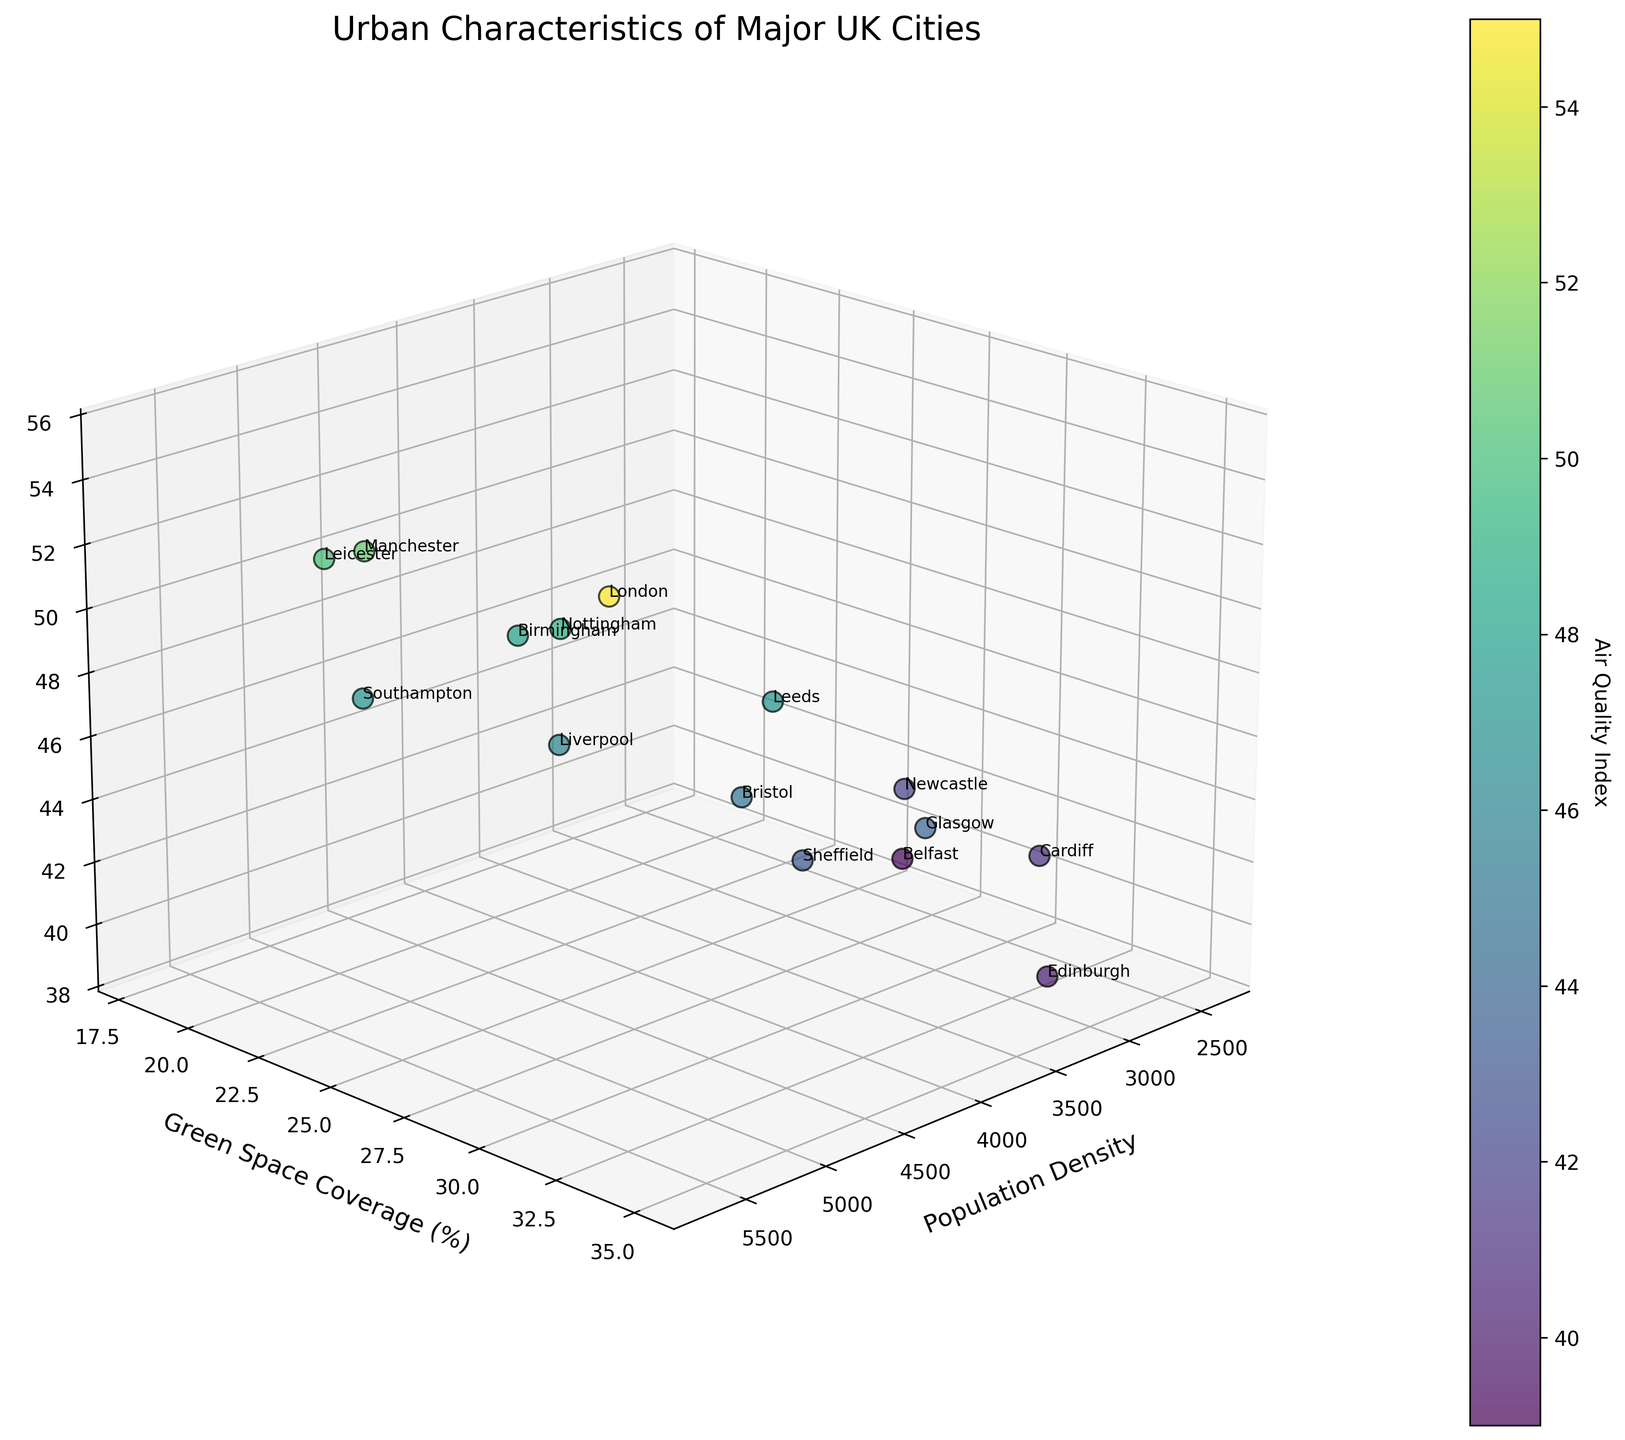How many cities are plotted in the figure? Count the number of labels or data points marked in the 3D scatter plot. There should be 15 cities listed in the provided data.
Answer: 15 Which city has the highest population density? Look at the x-axis representing the population density and find the data point farthest to the right. The label for this point is "London."
Answer: London What is the green space coverage for Edinburgh? Locate Edinburgh's data point label and then trace it to the y-axis. The value is stated as 35%.
Answer: 35% Which city has the best air quality index? The best air quality index has the lowest value on the z-axis. By examining the plot, Belfast has the lowest z-value for air quality.
Answer: Belfast Which city combines high population density with relatively high green space coverage? Look for a city that is far to the right on the x-axis (high population density) and relatively high on the y-axis (green space coverage). London fits this criterion with 5700 population density and 33% green space coverage.
Answer: London How does the air quality index for Glasgow compare to that of Nottingham? Identify the z-values for both Glasgow and Nottingham. Glasgow's air quality index is 44, and Nottingham's is 49, so Glasgow has a better air quality index.
Answer: Glasgow Calculate the average green space coverage for the cities plotted. Sum the green space coverage values and divide by the number of cities. \( \frac{33 + 22 + 20 + 28 + 32 + 25 + 30 + 35 + 29 + 27 + 31 + 24 + 18 + 26 + 21}{15} = \frac{401}{15} \approx 26.73 \).
Answer: 26.73% Which cities have both population densities below 3000 and air quality indices below 45? From the data, the cities that meet both criteria are Cardiff (population density: 2500, air quality index: 41) and Belfast (population density: 2400, air quality index: 39).
Answer: Cardiff, Belfast What city lies closest to the average green space coverage value of 26.73%? Identify which city's green space coverage is nearest to the average. Both Newcastle and Cardiff have values close to the average. Newcastle (27%) or Cardiff (31%). Since 27% is closer to 26.73%, Newcastle is the closest.
Answer: Newcastle 